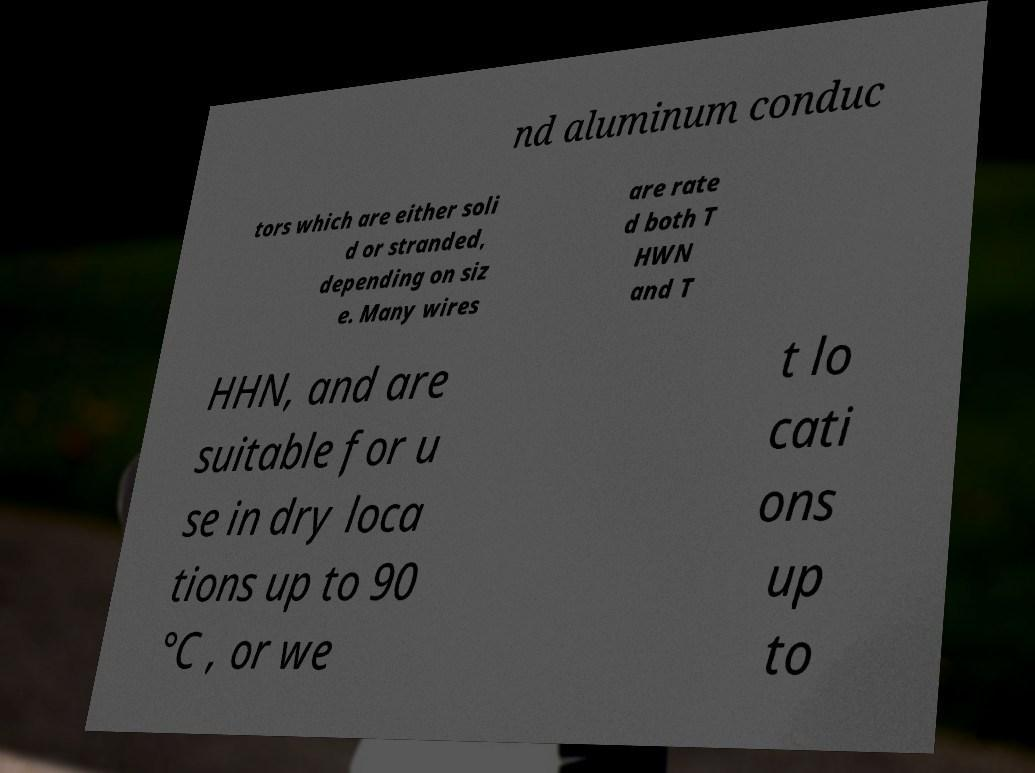Can you read and provide the text displayed in the image?This photo seems to have some interesting text. Can you extract and type it out for me? nd aluminum conduc tors which are either soli d or stranded, depending on siz e. Many wires are rate d both T HWN and T HHN, and are suitable for u se in dry loca tions up to 90 °C , or we t lo cati ons up to 